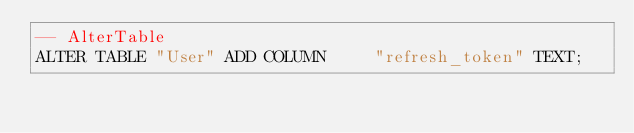<code> <loc_0><loc_0><loc_500><loc_500><_SQL_>-- AlterTable
ALTER TABLE "User" ADD COLUMN     "refresh_token" TEXT;
</code> 